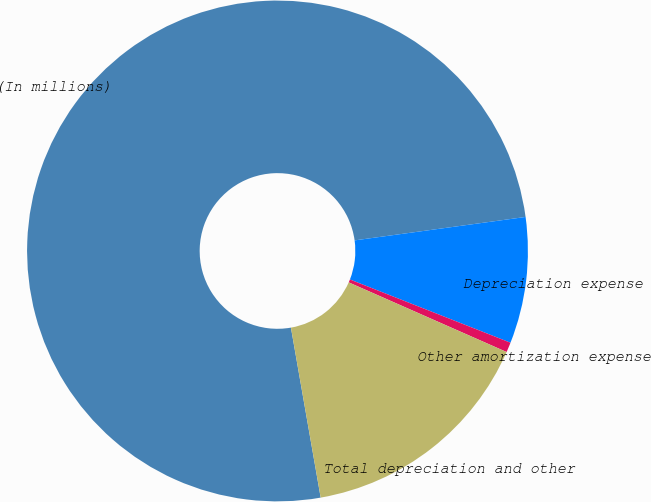Convert chart to OTSL. <chart><loc_0><loc_0><loc_500><loc_500><pie_chart><fcel>(In millions)<fcel>Depreciation expense<fcel>Other amortization expense<fcel>Total depreciation and other<nl><fcel>75.59%<fcel>8.14%<fcel>0.64%<fcel>15.63%<nl></chart> 